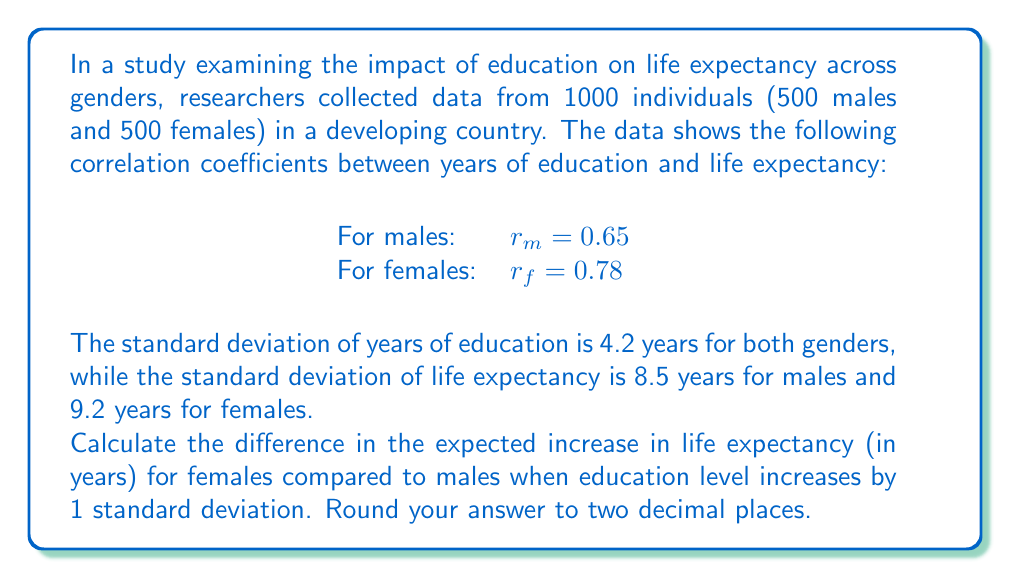Teach me how to tackle this problem. To solve this problem, we'll use the concept of regression slope and its relationship with correlation coefficient. The steps are as follows:

1) The regression slope (b) is given by the formula:
   $$b = r \cdot \frac{s_y}{s_x}$$
   where r is the correlation coefficient, $s_y$ is the standard deviation of the dependent variable (life expectancy), and $s_x$ is the standard deviation of the independent variable (years of education).

2) For males:
   $$b_m = 0.65 \cdot \frac{8.5}{4.2} = 1.3155$$

3) For females:
   $$b_f = 0.78 \cdot \frac{9.2}{4.2} = 1.7080$$

4) These slopes represent the expected increase in life expectancy (in years) for each year increase in education.

5) To find the increase for one standard deviation of education (4.2 years):
   For males: $1.3155 \cdot 4.2 = 5.5251$ years
   For females: $1.7080 \cdot 4.2 = 7.1736$ years

6) The difference between females and males:
   $7.1736 - 5.5251 = 1.6485$ years

7) Rounding to two decimal places: 1.65 years

This result suggests that increasing education by one standard deviation is associated with a larger increase in life expectancy for females compared to males, which could be an important finding for a sociologist studying gender inequality in health outcomes.
Answer: 1.65 years 